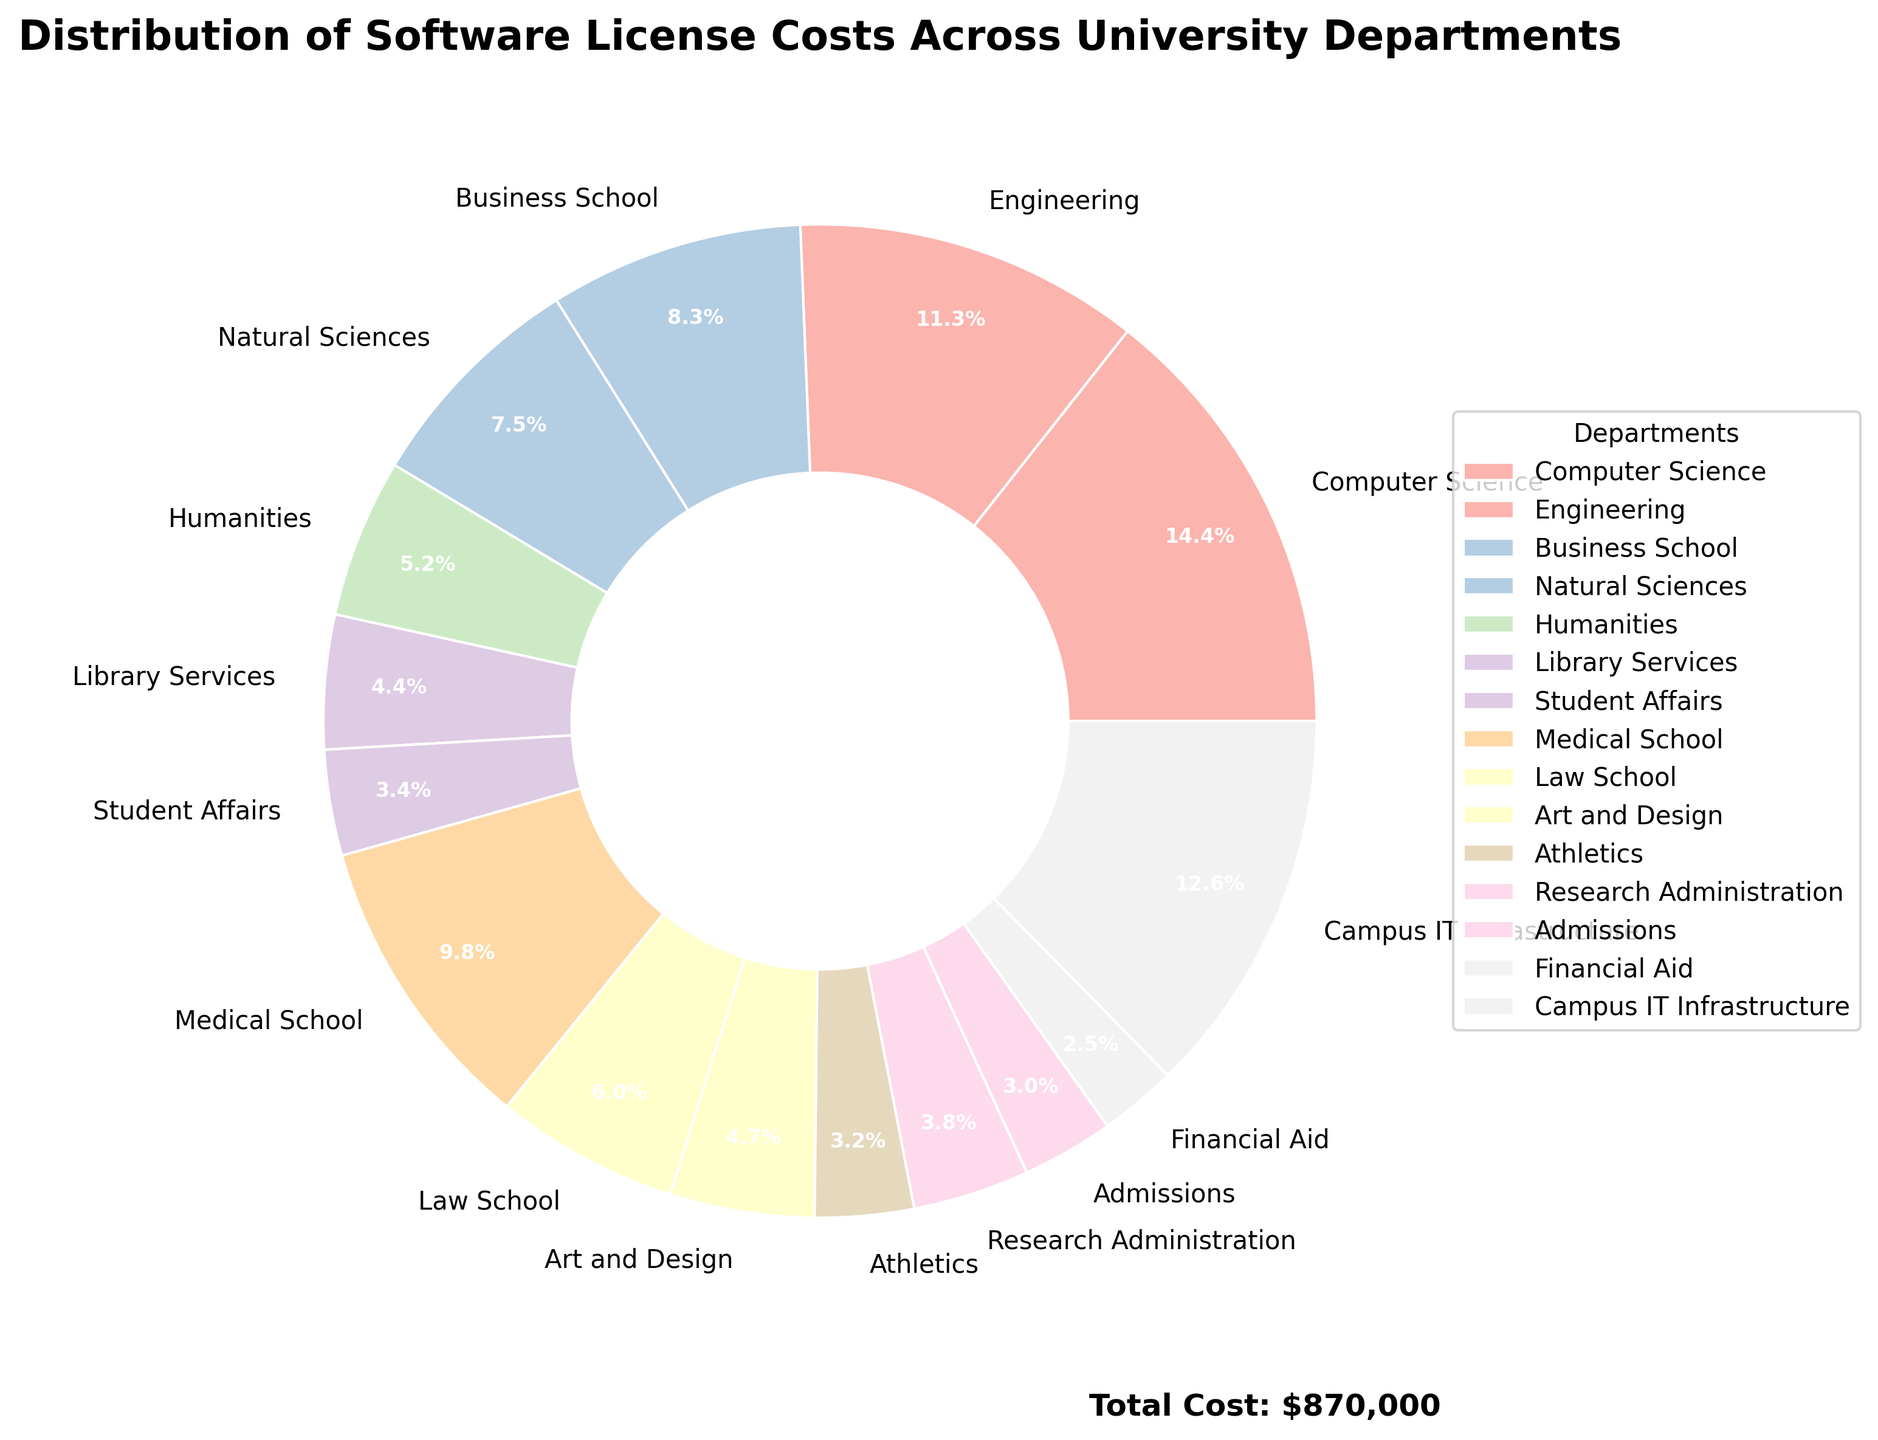Which department has the highest software license cost? The pie chart shows that the Computer Science department has the largest wedge, indicating it has the highest software license cost.
Answer: Computer Science Which two departments have the lowest software license costs? The pie chart wedges for Admissions and Financial Aid are the smallest, indicating these departments have the lowest costs.
Answer: Admissions and Financial Aid What's the combined software license cost for Computer Science and Campus IT Infrastructure? The chart shows the costs for Computer Science ($125,000) and Campus IT Infrastructure ($110,000). Adding these gives $125,000 + $110,000 = $235,000.
Answer: $235,000 How much more does the Engineering department spend on software licenses compared to the Business School? The pie chart shows that the Engineering department spends $98,000 and the Business School spends $72,000. The difference is $98,000 - $72,000 = $26,000.
Answer: $26,000 What is the total annual software license cost for all the departments combined? The annotation on the pie chart indicates the total software license cost is $765,000.
Answer: $765,000 Which department has a software license cost nearest to the cost of the Humanities department? The Humanities department’s cost is $45,000. The Law School’s cost is $52,000 and Art and Design is $41,000. The Art and Design department is closest at $41,000.
Answer: Art and Design What percentage of the total software license costs does the Medical School contribute? From the pie chart, the Medical School is labeled with $85,000. The total cost is $765,000. The percentage is ($85,000 / $765,000) * 100 ≈ 11.1%.
Answer: 11.1% Compare the combined annual license costs for the Natural Sciences and the Humanities to the license costs for Campus IT Infrastructure. The Natural Sciences cost $65,000 and the Humanities cost $45,000. Combined, this is $65,000 + $45,000 = $110,000. Campus IT Infrastructure also costs $110,000.
Answer: They are equal If the university wants to cut down only one department's license cost by 10% and redistribute it equally among Financial Aid, Athletics, and Admissions, which department’s cost cutting would result in the most significant redistribution amount per department? Cutting 10% of the Computer Science department's $125,000 would save $12,500. Redistributing this evenly among Financial Aid, Athletics, and Admissions results in $12,500 / 3 ≈ $4,167 per department. This is the highest significant amount compared to other departments.
Answer: Computer Science 